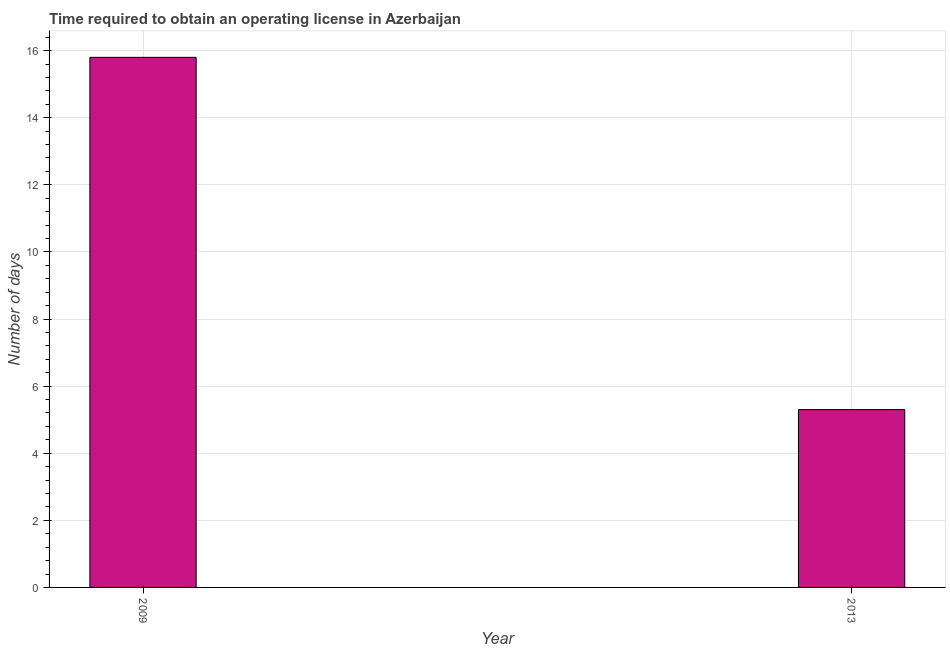What is the title of the graph?
Ensure brevity in your answer.  Time required to obtain an operating license in Azerbaijan. What is the label or title of the Y-axis?
Your answer should be compact. Number of days. Across all years, what is the minimum number of days to obtain operating license?
Your answer should be compact. 5.3. In which year was the number of days to obtain operating license maximum?
Offer a very short reply. 2009. What is the sum of the number of days to obtain operating license?
Provide a short and direct response. 21.1. What is the difference between the number of days to obtain operating license in 2009 and 2013?
Keep it short and to the point. 10.5. What is the average number of days to obtain operating license per year?
Ensure brevity in your answer.  10.55. What is the median number of days to obtain operating license?
Offer a very short reply. 10.55. In how many years, is the number of days to obtain operating license greater than 5.2 days?
Provide a succinct answer. 2. Do a majority of the years between 2009 and 2013 (inclusive) have number of days to obtain operating license greater than 7.2 days?
Provide a short and direct response. No. What is the ratio of the number of days to obtain operating license in 2009 to that in 2013?
Your response must be concise. 2.98. In how many years, is the number of days to obtain operating license greater than the average number of days to obtain operating license taken over all years?
Your answer should be very brief. 1. How many bars are there?
Ensure brevity in your answer.  2. How many years are there in the graph?
Give a very brief answer. 2. What is the Number of days of 2009?
Offer a terse response. 15.8. What is the Number of days of 2013?
Offer a very short reply. 5.3. What is the difference between the Number of days in 2009 and 2013?
Provide a short and direct response. 10.5. What is the ratio of the Number of days in 2009 to that in 2013?
Your answer should be compact. 2.98. 